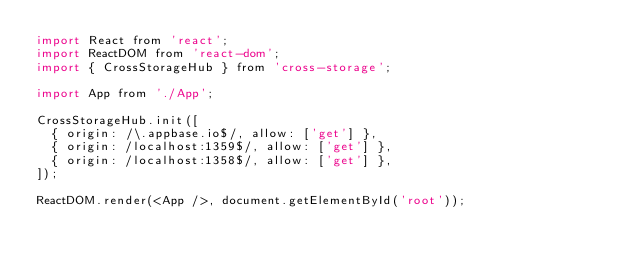Convert code to text. <code><loc_0><loc_0><loc_500><loc_500><_JavaScript_>import React from 'react';
import ReactDOM from 'react-dom';
import { CrossStorageHub } from 'cross-storage';

import App from './App';

CrossStorageHub.init([
  { origin: /\.appbase.io$/, allow: ['get'] },
  { origin: /localhost:1359$/, allow: ['get'] },
  { origin: /localhost:1358$/, allow: ['get'] },
]);

ReactDOM.render(<App />, document.getElementById('root'));
</code> 